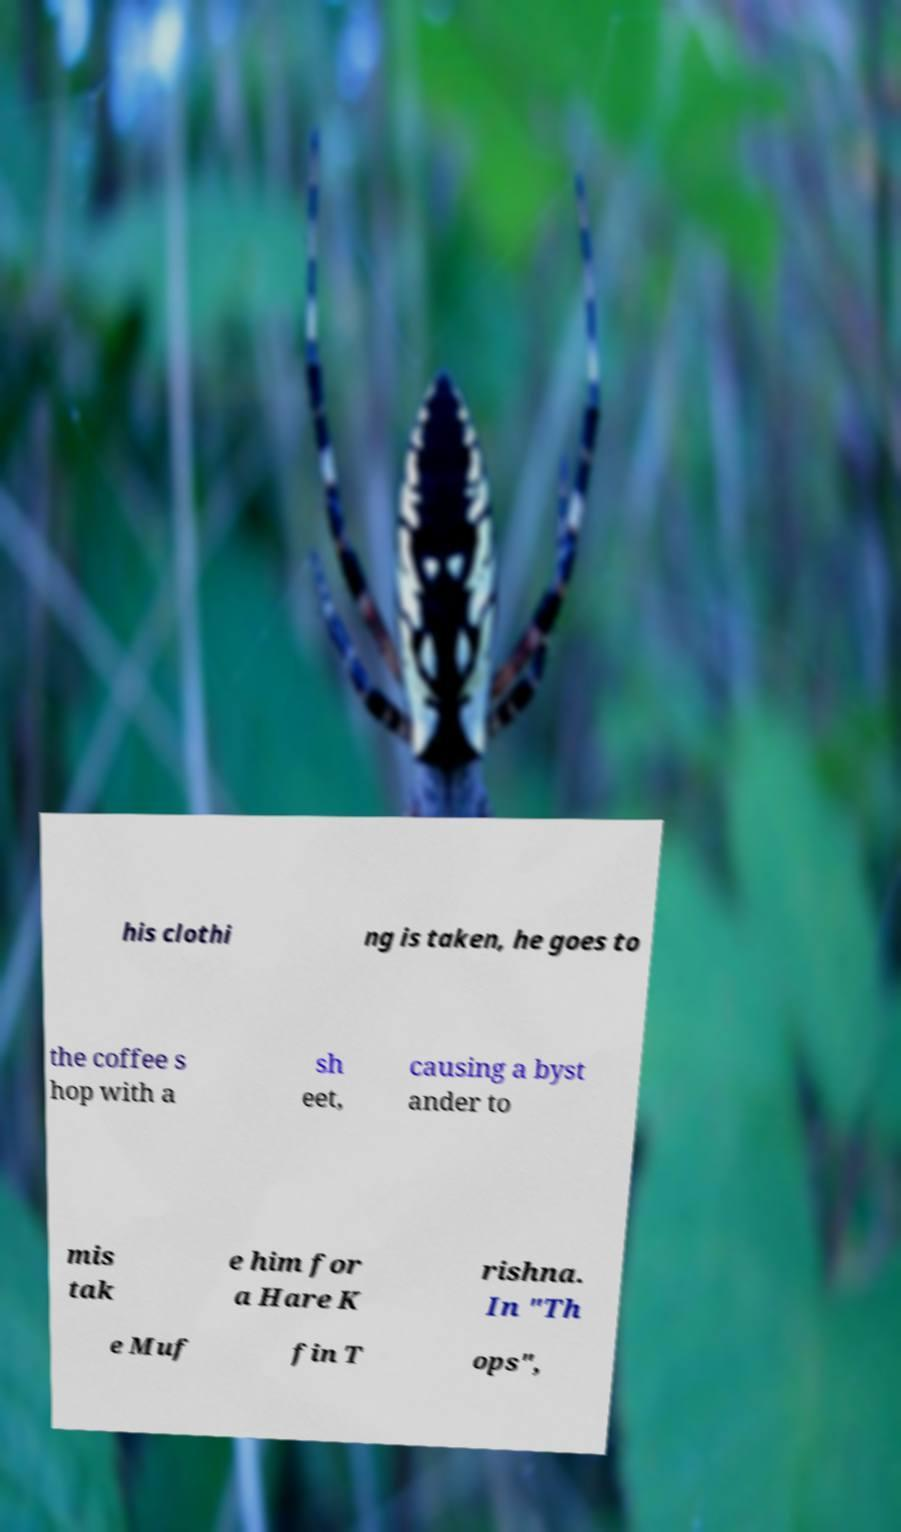Could you assist in decoding the text presented in this image and type it out clearly? his clothi ng is taken, he goes to the coffee s hop with a sh eet, causing a byst ander to mis tak e him for a Hare K rishna. In "Th e Muf fin T ops", 